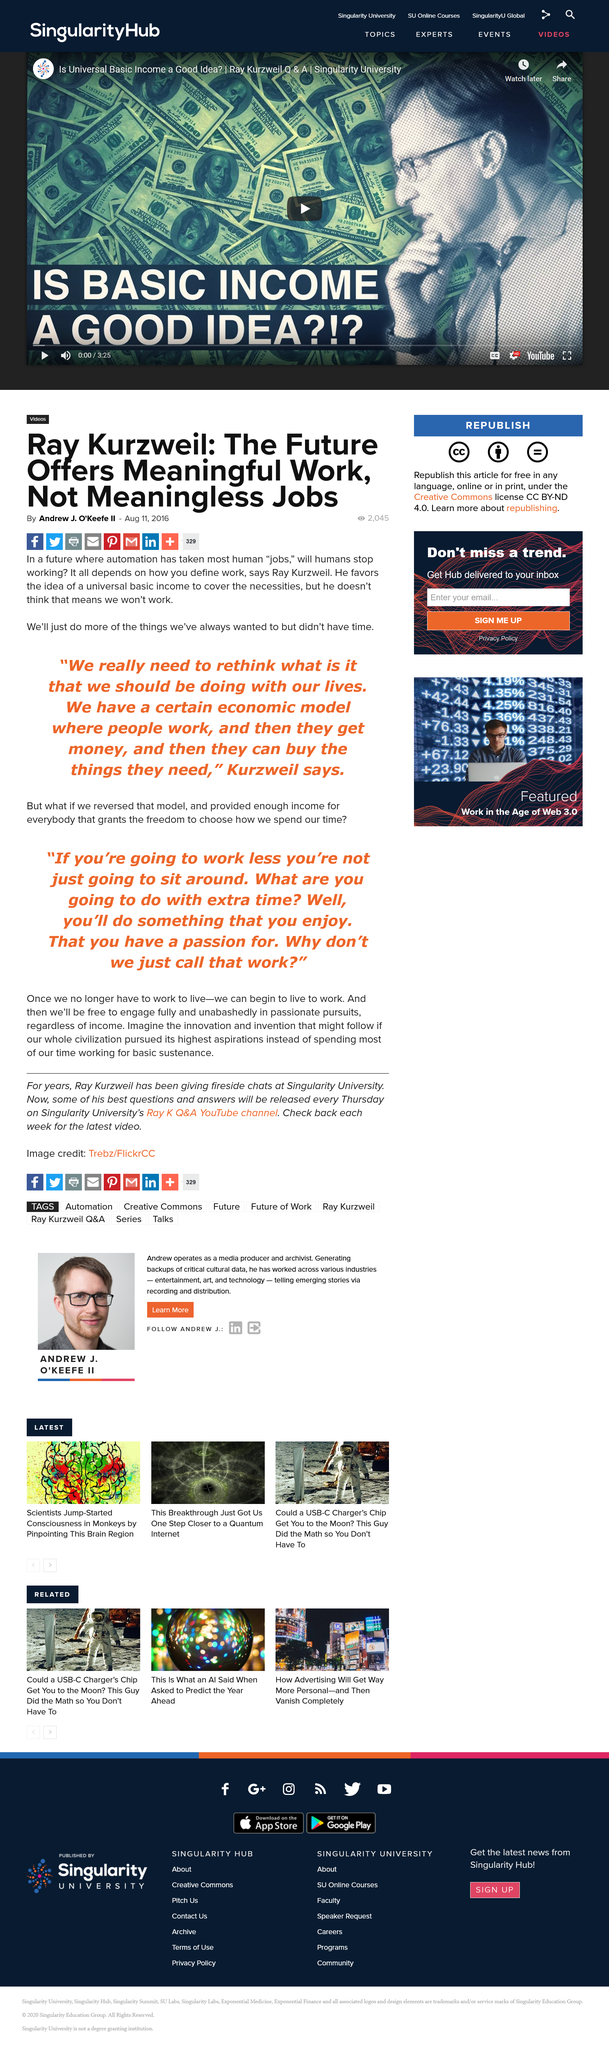Identify some key points in this picture. Ray Kurzweil favors the concept of a universal basic income to cover basic necessities. According to Mr. Kurzweil, when automation has taken over most human jobs, we will have more time to pursue the activities we have always desired but did not have the opportunity to do so. Mr. Kurzweil describes an economic model in which individuals work, receive compensation in the form of money, and then use that money to acquire the necessities and luxuries they require. 